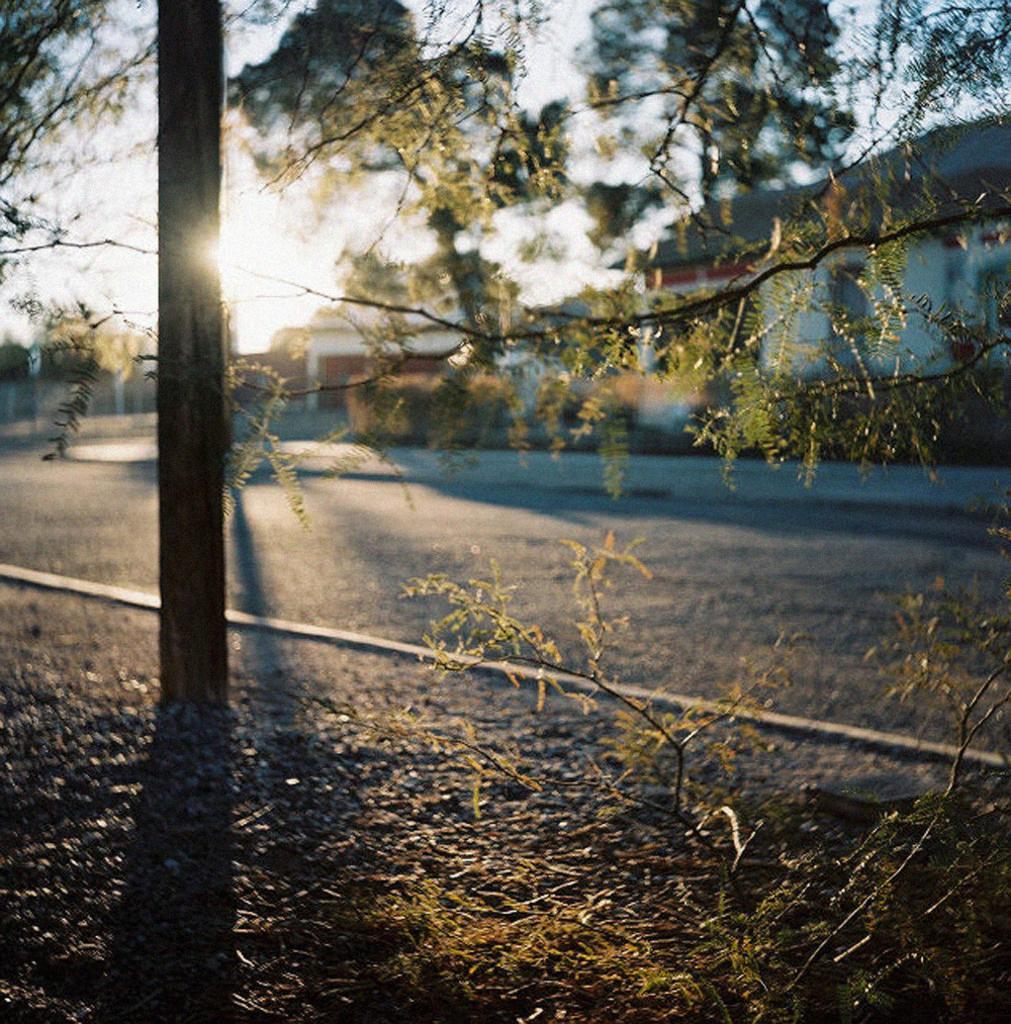In one or two sentences, can you explain what this image depicts? This image is taken outdoors. At the bottom of the image there is a ground with a plant on it and there is a road. On the left side of the image there is a tree. On the right side of the image there are a few houses. At the top of the image there is a sky with sun. 